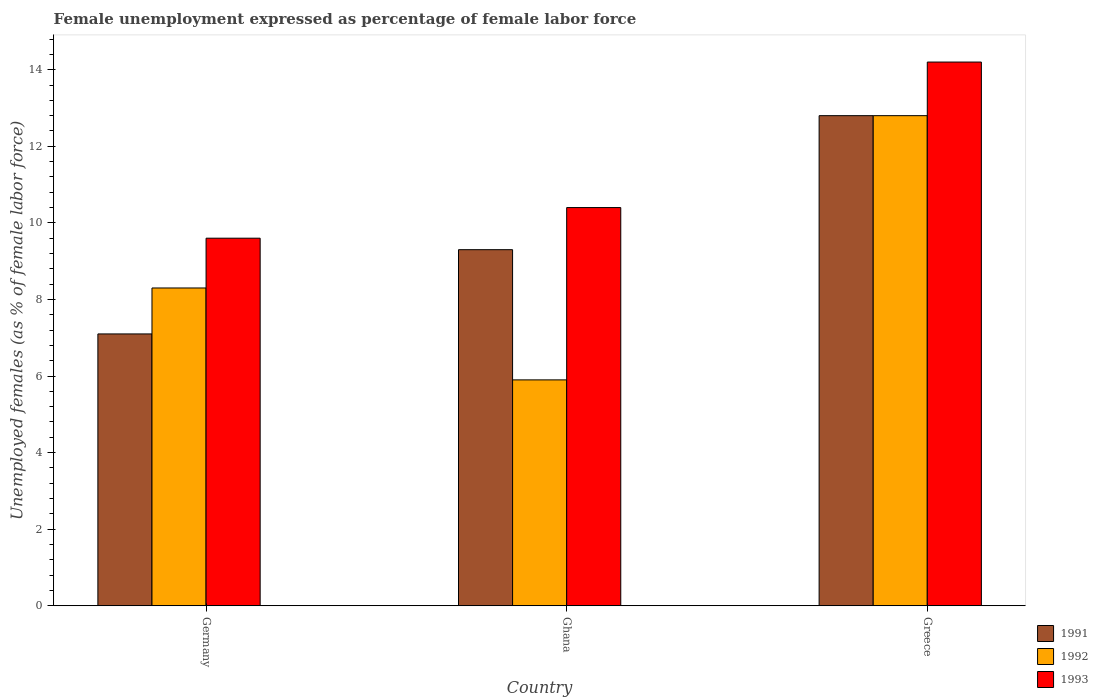How many different coloured bars are there?
Ensure brevity in your answer.  3. How many bars are there on the 1st tick from the left?
Offer a very short reply. 3. What is the label of the 3rd group of bars from the left?
Ensure brevity in your answer.  Greece. In how many cases, is the number of bars for a given country not equal to the number of legend labels?
Ensure brevity in your answer.  0. What is the unemployment in females in in 1993 in Germany?
Provide a succinct answer. 9.6. Across all countries, what is the maximum unemployment in females in in 1993?
Offer a terse response. 14.2. Across all countries, what is the minimum unemployment in females in in 1992?
Offer a terse response. 5.9. In which country was the unemployment in females in in 1993 maximum?
Your answer should be very brief. Greece. In which country was the unemployment in females in in 1992 minimum?
Make the answer very short. Ghana. What is the total unemployment in females in in 1993 in the graph?
Offer a terse response. 34.2. What is the difference between the unemployment in females in in 1992 in Germany and that in Greece?
Keep it short and to the point. -4.5. What is the difference between the unemployment in females in in 1992 in Greece and the unemployment in females in in 1993 in Germany?
Your answer should be compact. 3.2. What is the average unemployment in females in in 1993 per country?
Make the answer very short. 11.4. What is the difference between the unemployment in females in of/in 1993 and unemployment in females in of/in 1991 in Greece?
Your answer should be compact. 1.4. What is the ratio of the unemployment in females in in 1991 in Germany to that in Ghana?
Offer a very short reply. 0.76. Is the unemployment in females in in 1992 in Germany less than that in Greece?
Your response must be concise. Yes. What is the difference between the highest and the second highest unemployment in females in in 1993?
Provide a succinct answer. -0.8. What is the difference between the highest and the lowest unemployment in females in in 1993?
Your answer should be compact. 4.6. What does the 1st bar from the right in Greece represents?
Your answer should be very brief. 1993. How many bars are there?
Provide a succinct answer. 9. Are all the bars in the graph horizontal?
Your response must be concise. No. How many countries are there in the graph?
Provide a short and direct response. 3. What is the difference between two consecutive major ticks on the Y-axis?
Your answer should be very brief. 2. Does the graph contain any zero values?
Your response must be concise. No. How are the legend labels stacked?
Offer a very short reply. Vertical. What is the title of the graph?
Your answer should be compact. Female unemployment expressed as percentage of female labor force. What is the label or title of the Y-axis?
Ensure brevity in your answer.  Unemployed females (as % of female labor force). What is the Unemployed females (as % of female labor force) of 1991 in Germany?
Ensure brevity in your answer.  7.1. What is the Unemployed females (as % of female labor force) of 1992 in Germany?
Your answer should be compact. 8.3. What is the Unemployed females (as % of female labor force) of 1993 in Germany?
Your answer should be very brief. 9.6. What is the Unemployed females (as % of female labor force) of 1991 in Ghana?
Make the answer very short. 9.3. What is the Unemployed females (as % of female labor force) of 1992 in Ghana?
Your answer should be compact. 5.9. What is the Unemployed females (as % of female labor force) of 1993 in Ghana?
Give a very brief answer. 10.4. What is the Unemployed females (as % of female labor force) in 1991 in Greece?
Your answer should be compact. 12.8. What is the Unemployed females (as % of female labor force) of 1992 in Greece?
Your response must be concise. 12.8. What is the Unemployed females (as % of female labor force) in 1993 in Greece?
Provide a succinct answer. 14.2. Across all countries, what is the maximum Unemployed females (as % of female labor force) of 1991?
Give a very brief answer. 12.8. Across all countries, what is the maximum Unemployed females (as % of female labor force) in 1992?
Keep it short and to the point. 12.8. Across all countries, what is the maximum Unemployed females (as % of female labor force) of 1993?
Make the answer very short. 14.2. Across all countries, what is the minimum Unemployed females (as % of female labor force) of 1991?
Offer a terse response. 7.1. Across all countries, what is the minimum Unemployed females (as % of female labor force) of 1992?
Offer a terse response. 5.9. Across all countries, what is the minimum Unemployed females (as % of female labor force) of 1993?
Your answer should be compact. 9.6. What is the total Unemployed females (as % of female labor force) in 1991 in the graph?
Your response must be concise. 29.2. What is the total Unemployed females (as % of female labor force) in 1992 in the graph?
Give a very brief answer. 27. What is the total Unemployed females (as % of female labor force) in 1993 in the graph?
Your answer should be very brief. 34.2. What is the difference between the Unemployed females (as % of female labor force) of 1991 in Germany and that in Ghana?
Keep it short and to the point. -2.2. What is the difference between the Unemployed females (as % of female labor force) in 1993 in Germany and that in Ghana?
Provide a succinct answer. -0.8. What is the difference between the Unemployed females (as % of female labor force) in 1992 in Germany and that in Greece?
Your response must be concise. -4.5. What is the difference between the Unemployed females (as % of female labor force) of 1993 in Germany and that in Greece?
Your answer should be compact. -4.6. What is the difference between the Unemployed females (as % of female labor force) of 1991 in Ghana and that in Greece?
Your answer should be very brief. -3.5. What is the difference between the Unemployed females (as % of female labor force) of 1993 in Ghana and that in Greece?
Give a very brief answer. -3.8. What is the difference between the Unemployed females (as % of female labor force) in 1991 in Germany and the Unemployed females (as % of female labor force) in 1992 in Ghana?
Give a very brief answer. 1.2. What is the difference between the Unemployed females (as % of female labor force) of 1991 in Germany and the Unemployed females (as % of female labor force) of 1993 in Greece?
Offer a very short reply. -7.1. What is the difference between the Unemployed females (as % of female labor force) of 1991 in Ghana and the Unemployed females (as % of female labor force) of 1992 in Greece?
Your response must be concise. -3.5. What is the difference between the Unemployed females (as % of female labor force) in 1992 in Ghana and the Unemployed females (as % of female labor force) in 1993 in Greece?
Your answer should be very brief. -8.3. What is the average Unemployed females (as % of female labor force) of 1991 per country?
Provide a succinct answer. 9.73. What is the average Unemployed females (as % of female labor force) of 1992 per country?
Provide a succinct answer. 9. What is the average Unemployed females (as % of female labor force) in 1993 per country?
Make the answer very short. 11.4. What is the difference between the Unemployed females (as % of female labor force) in 1991 and Unemployed females (as % of female labor force) in 1992 in Germany?
Provide a succinct answer. -1.2. What is the difference between the Unemployed females (as % of female labor force) of 1992 and Unemployed females (as % of female labor force) of 1993 in Germany?
Provide a succinct answer. -1.3. What is the difference between the Unemployed females (as % of female labor force) of 1991 and Unemployed females (as % of female labor force) of 1993 in Ghana?
Make the answer very short. -1.1. What is the difference between the Unemployed females (as % of female labor force) in 1992 and Unemployed females (as % of female labor force) in 1993 in Ghana?
Your answer should be compact. -4.5. What is the difference between the Unemployed females (as % of female labor force) of 1991 and Unemployed females (as % of female labor force) of 1992 in Greece?
Make the answer very short. 0. What is the difference between the Unemployed females (as % of female labor force) in 1991 and Unemployed females (as % of female labor force) in 1993 in Greece?
Ensure brevity in your answer.  -1.4. What is the difference between the Unemployed females (as % of female labor force) of 1992 and Unemployed females (as % of female labor force) of 1993 in Greece?
Your answer should be very brief. -1.4. What is the ratio of the Unemployed females (as % of female labor force) in 1991 in Germany to that in Ghana?
Your answer should be compact. 0.76. What is the ratio of the Unemployed females (as % of female labor force) in 1992 in Germany to that in Ghana?
Keep it short and to the point. 1.41. What is the ratio of the Unemployed females (as % of female labor force) of 1991 in Germany to that in Greece?
Provide a succinct answer. 0.55. What is the ratio of the Unemployed females (as % of female labor force) in 1992 in Germany to that in Greece?
Provide a succinct answer. 0.65. What is the ratio of the Unemployed females (as % of female labor force) in 1993 in Germany to that in Greece?
Your response must be concise. 0.68. What is the ratio of the Unemployed females (as % of female labor force) of 1991 in Ghana to that in Greece?
Give a very brief answer. 0.73. What is the ratio of the Unemployed females (as % of female labor force) of 1992 in Ghana to that in Greece?
Provide a succinct answer. 0.46. What is the ratio of the Unemployed females (as % of female labor force) in 1993 in Ghana to that in Greece?
Keep it short and to the point. 0.73. What is the difference between the highest and the second highest Unemployed females (as % of female labor force) of 1993?
Your answer should be very brief. 3.8. What is the difference between the highest and the lowest Unemployed females (as % of female labor force) in 1991?
Ensure brevity in your answer.  5.7. What is the difference between the highest and the lowest Unemployed females (as % of female labor force) in 1993?
Offer a very short reply. 4.6. 